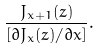<formula> <loc_0><loc_0><loc_500><loc_500>\frac { J _ { x + 1 } ( z ) } { [ { \partial J _ { x } ( z ) / } { \partial x } ] } .</formula> 